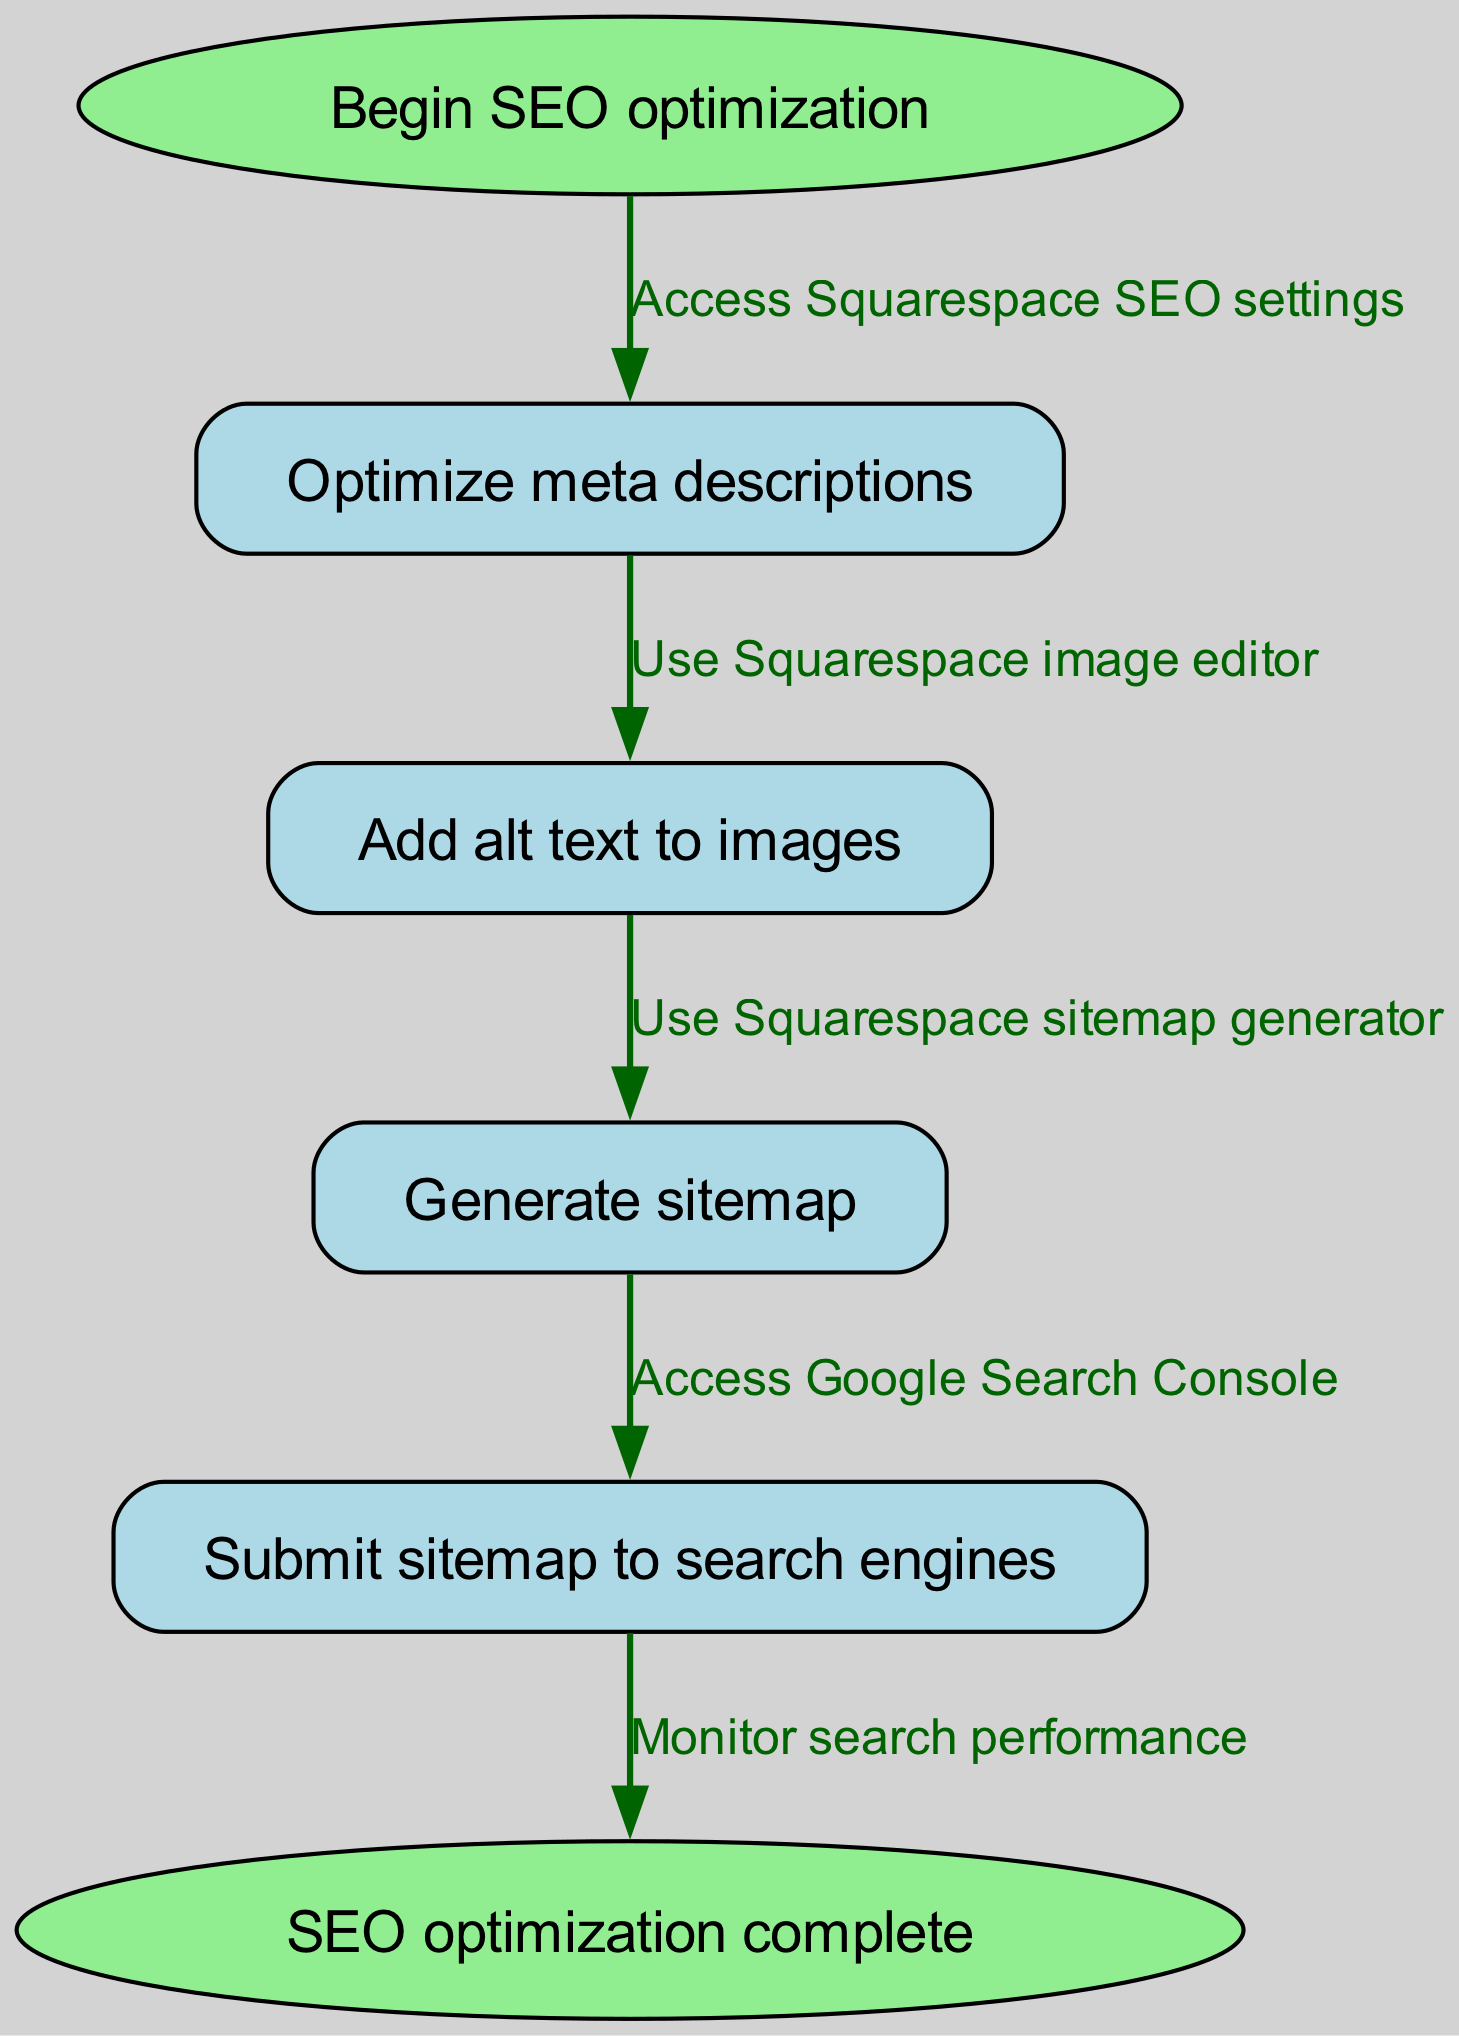What is the starting point of the SEO optimization in the diagram? The starting point is identified in the diagram as the first node labeled "Begin SEO optimization."
Answer: Begin SEO optimization How many nodes are present in the diagram? The diagram lists a total of six nodes: start, optimize meta descriptions, add alt text to images, generate sitemap, submit sitemap to search engines, and end.
Answer: 6 What action follows "Optimize meta descriptions"? From the diagram, the action that follows "Optimize meta descriptions" is "Add alt text to images," as indicated by the directed edge leading to that node.
Answer: Add alt text to images What is the final step in the SEO optimization workflow? The final step in the workflow is shown as the last node labeled "SEO optimization complete."
Answer: SEO optimization complete What is the relationship between "Generate sitemap" and "Submit sitemap to search engines"? The diagram shows that "Generate sitemap" leads to "Submit sitemap to search engines" via a directed edge that indicates the action of accessing Google Search Console to perform the submission.
Answer: Access Google Search Console What is the flow of actions from the start to the end of the optimization process? The flow starts with “Begin SEO optimization,” then “Optimize meta descriptions,” leads to “Add alt text to images,” followed by “Generate sitemap,” proceeds to “Submit sitemap to search engines,” and concludes with “SEO optimization complete.” This indicates a sequential process of enhancements.
Answer: Begin SEO optimization → Optimize meta descriptions → Add alt text to images → Generate sitemap → Submit sitemap to search engines → SEO optimization complete What task is performed after adding alt text? After adding alt text, the next task to be performed is generating a sitemap, as shown by the directed edge connecting those nodes.
Answer: Generate sitemap How many edges are there connecting the nodes in the diagram? The diagram includes a total of five edges that connect the six nodes, showing the relationship and sequence of actions taken during the SEO optimization process.
Answer: 5 